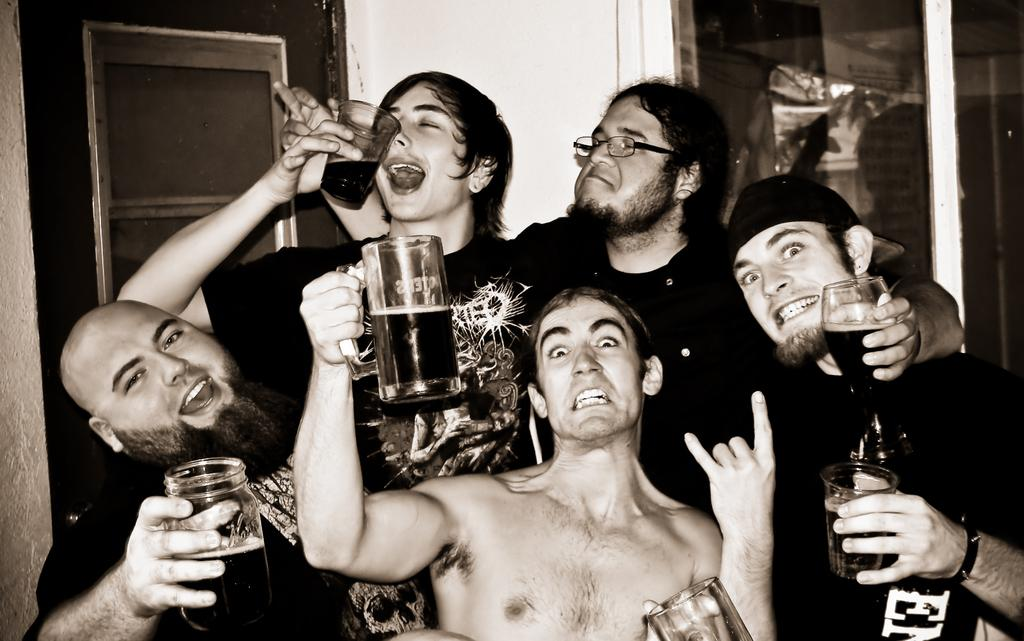How many people are in the image? There are persons in the image. What are the persons holding in their hands? The persons are holding glasses in their hands. What can be seen in the background of the image? There is a door visible in the background of the image. What type of health advice is the maid giving to the persons in the image? There is no maid present in the image, and therefore no health advice can be given. 